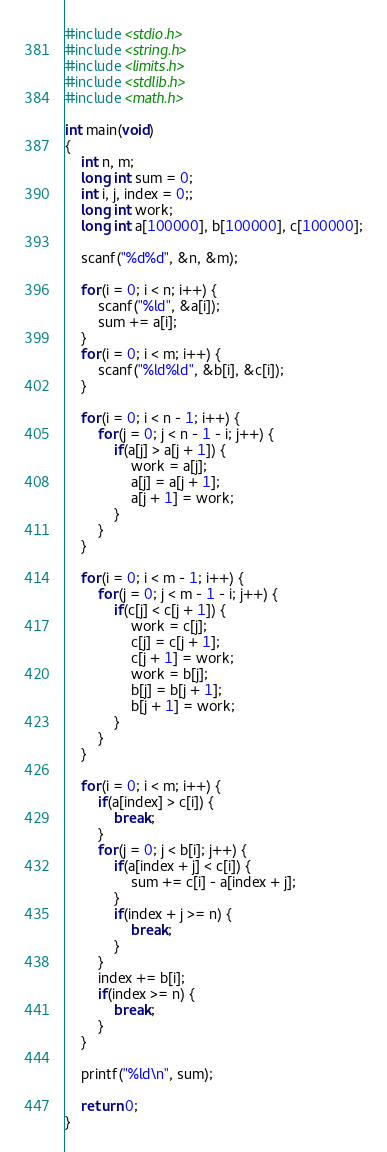<code> <loc_0><loc_0><loc_500><loc_500><_C_>#include <stdio.h>
#include <string.h>
#include <limits.h>
#include <stdlib.h>
#include <math.h>

int main(void)
{
	int n, m;
	long int sum = 0;
	int i, j, index = 0;;
	long int work;
	long int a[100000], b[100000], c[100000];
	
	scanf("%d%d", &n, &m);
	
	for(i = 0; i < n; i++) {
		scanf("%ld", &a[i]);
		sum += a[i];
	}
	for(i = 0; i < m; i++) {
		scanf("%ld%ld", &b[i], &c[i]);
	}
	
	for(i = 0; i < n - 1; i++) {
		for(j = 0; j < n - 1 - i; j++) {
			if(a[j] > a[j + 1]) {
				work = a[j];
				a[j] = a[j + 1];
				a[j + 1] = work;
			}
		}
	}
	
	for(i = 0; i < m - 1; i++) {
		for(j = 0; j < m - 1 - i; j++) {
			if(c[j] < c[j + 1]) {
				work = c[j];
				c[j] = c[j + 1];
				c[j + 1] = work;
				work = b[j];
				b[j] = b[j + 1];
				b[j + 1] = work;
			}
		}
	}
	
	for(i = 0; i < m; i++) {
		if(a[index] > c[i]) {
			break;
		}
		for(j = 0; j < b[i]; j++) {
			if(a[index + j] < c[i]) {
				sum += c[i] - a[index + j];
			}
			if(index + j >= n) {
				break;
			}
		}
		index += b[i];
		if(index >= n) {
			break;
		}
	}
	
	printf("%ld\n", sum);
	
	return 0;
}</code> 